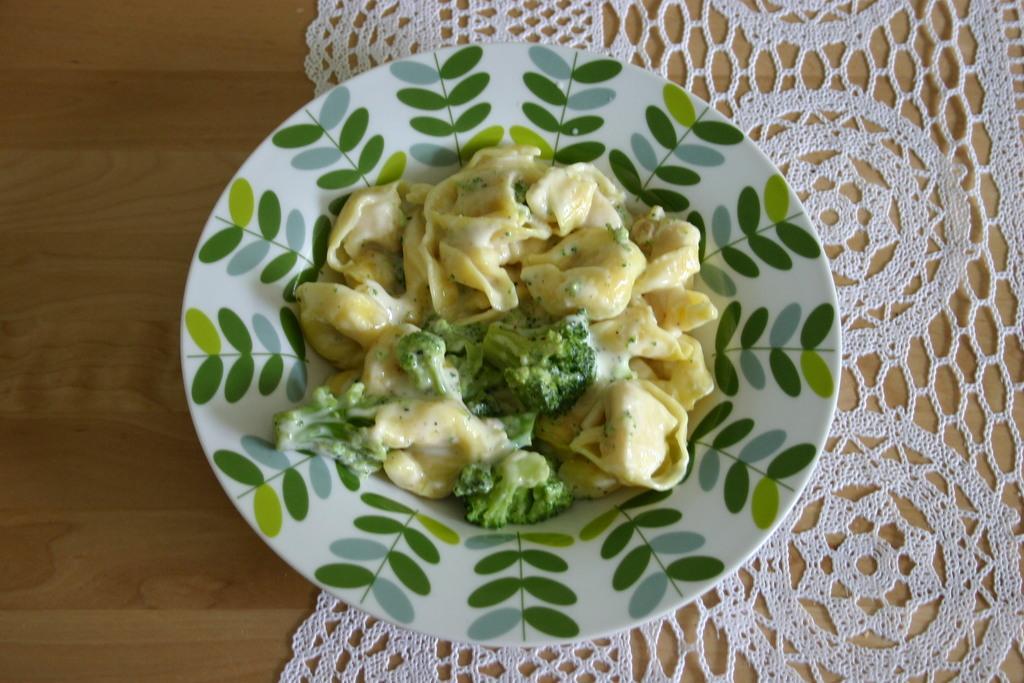Please provide a concise description of this image. There is a broccoli and other food items on a plate in the foreground area of the image, it seems like a cloth on the table. 